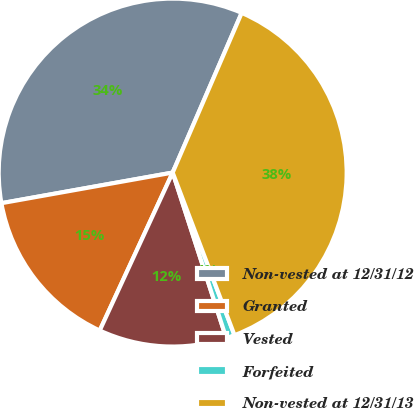Convert chart to OTSL. <chart><loc_0><loc_0><loc_500><loc_500><pie_chart><fcel>Non-vested at 12/31/12<fcel>Granted<fcel>Vested<fcel>Forfeited<fcel>Non-vested at 12/31/13<nl><fcel>34.31%<fcel>15.3%<fcel>11.87%<fcel>0.8%<fcel>37.73%<nl></chart> 